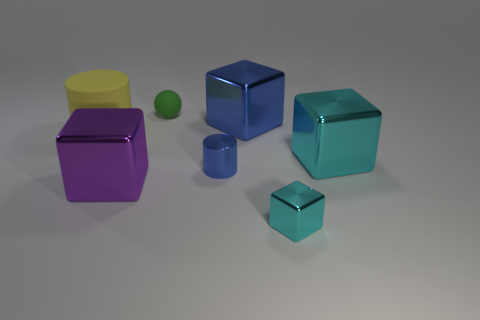There is another cube that is the same color as the tiny block; what size is it?
Your answer should be compact. Large. There is a object that is both to the left of the tiny metal cylinder and on the right side of the large purple block; what material is it?
Your answer should be very brief. Rubber. There is a tiny thing on the left side of the blue shiny cylinder; what color is it?
Your response must be concise. Green. What is the size of the purple metal cube?
Offer a very short reply. Large. Does the yellow cylinder have the same size as the blue metal thing that is behind the tiny blue metallic cylinder?
Offer a very short reply. Yes. What color is the small shiny thing behind the cyan metal block that is in front of the big cube that is right of the large blue block?
Keep it short and to the point. Blue. Is the large thing that is behind the rubber cylinder made of the same material as the small cylinder?
Your answer should be very brief. Yes. How many other objects are there of the same material as the small green object?
Offer a very short reply. 1. There is a yellow cylinder that is the same size as the purple block; what material is it?
Make the answer very short. Rubber. There is a thing that is to the left of the big purple thing; is it the same shape as the small object that is in front of the tiny blue cylinder?
Your response must be concise. No. 